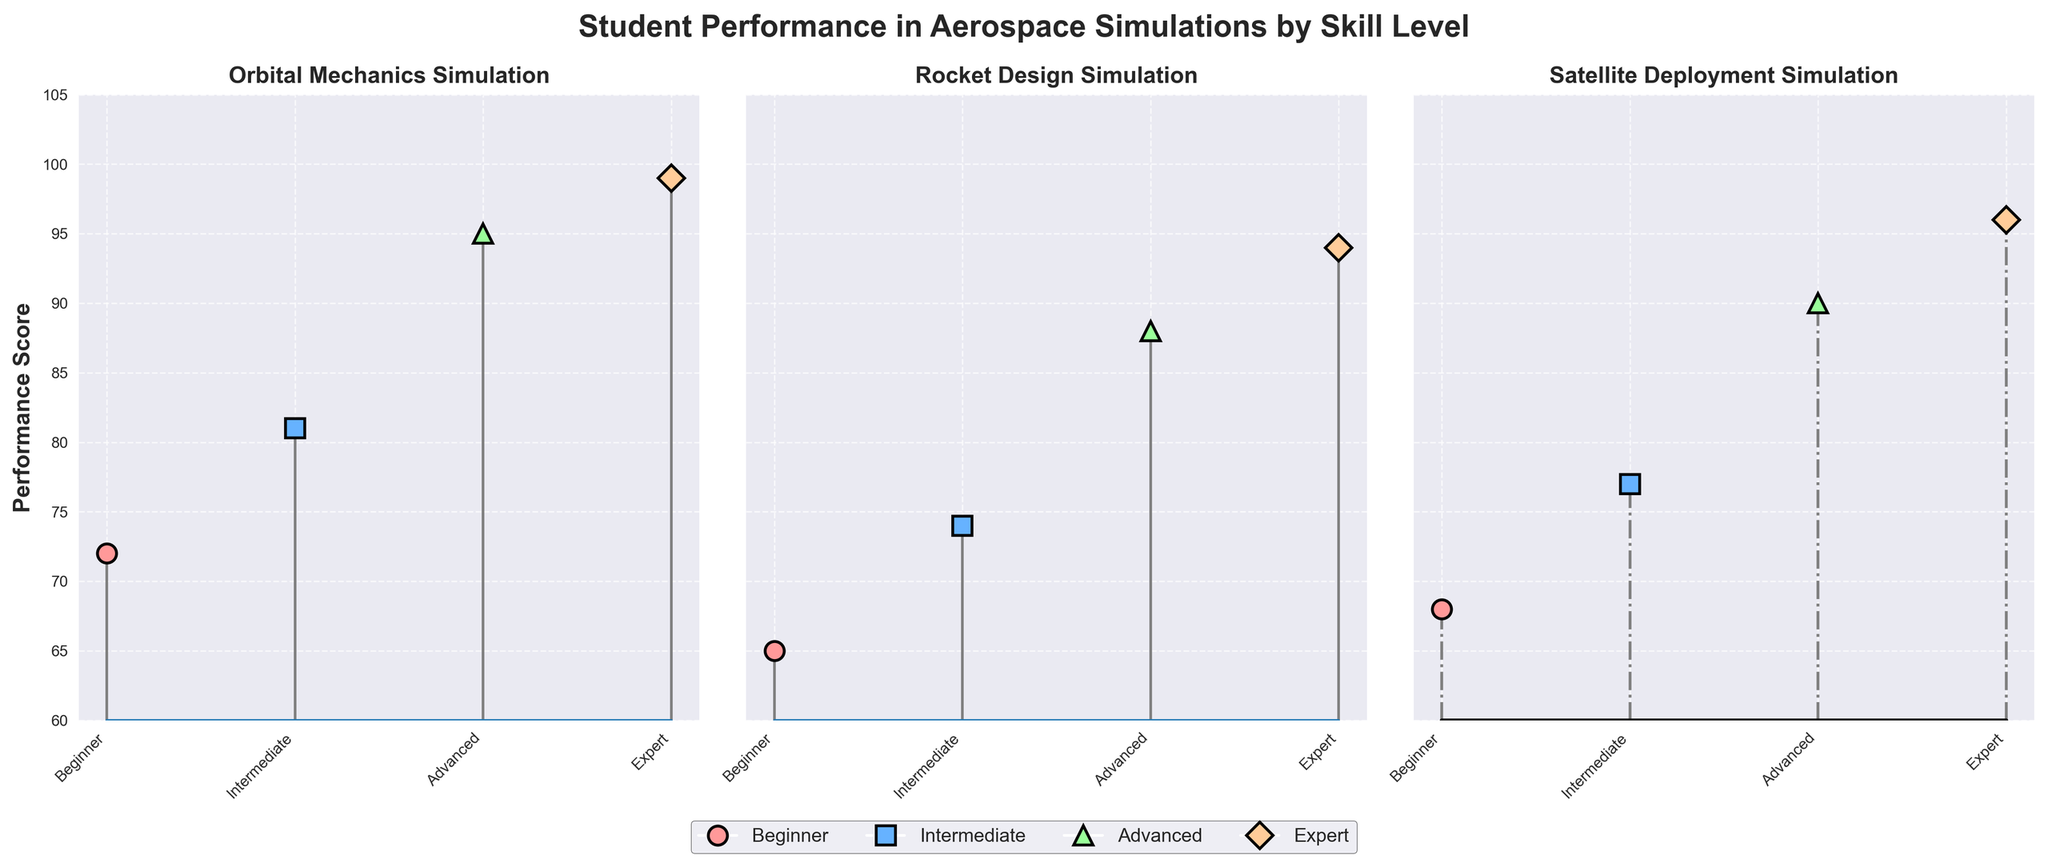What's the title of the figure? The title is displayed at the top of the figure in bold text and provides an overview of what the plot represents.
Answer: Student Performance in Aerospace Simulations by Skill Level Which simulation shows the highest performance score for the 'Expert' skill level? The 'Expert' skill level's performance scores can be found in the last (top) segments of each subplot. The highest score among those is visible at 99 in the Orbital Mechanics Simulation subplot.
Answer: Orbital Mechanics Simulation What's the difference in performance scores between 'Advanced' and 'Intermediate' skill levels in the Satellite Deployment Simulation? In the Satellite Deployment Simulation subplot, look for the scores for 'Advanced' (90) and 'Intermediate' (77), and find the difference between them (90 - 77).
Answer: 13 How does the performance score of the 'Beginner' skill level in Rocket Design Simulation compare to the 'Intermediate' skill level in the same simulation? In the Rocket Design Simulation subplot, compare the 'Beginner' score (65) with the 'Intermediate' score (74). The 'Intermediate' score is higher than the 'Beginner' score.
Answer: Intermediate is higher by 9 What's the average performance score across all simulations for the 'Advanced' skill level? Identify the 'Advanced' performance scores in each subplot: Orbital Mechanics (95), Rocket Design (88), and Satellite Deployment (90). Calculate the average: (95 + 88 + 90) / 3 = 91
Answer: 91 Which simulation shows the least variation in performance scores across different skill levels? For each simulation subplot, observe the range of scores from 'Beginner' to 'Expert'. The least variation is visible in the Rocket Design Simulation (from 65 to 94).
Answer: Rocket Design Simulation What is the overall trend in performance scores as skill levels increase? Across all simulations, notice the general pattern where the performance scores increase from 'Beginner' to 'Expert'.
Answer: Increasing trend Does any skill level score below 70 in Orbital Mechanics Simulation? In the Orbital Mechanics Simulation subplot, locate the scores for all skill levels (72, 81, 95, 99) and determine if any are below 70.
Answer: No What's the biggest improvement in performance score from 'Intermediate' to 'Advanced' skill levels in any simulation? Compare the score differences from 'Intermediate' to 'Advanced' in each simulation: Orbital Mechanics (95 - 81 = 14), Rocket Design (88 - 74 = 14), Satellite Deployment (90 - 77 = 13). The largest improvement is 14, found in both Orbital Mechanics and Rocket Design Simulations.
Answer: 14 